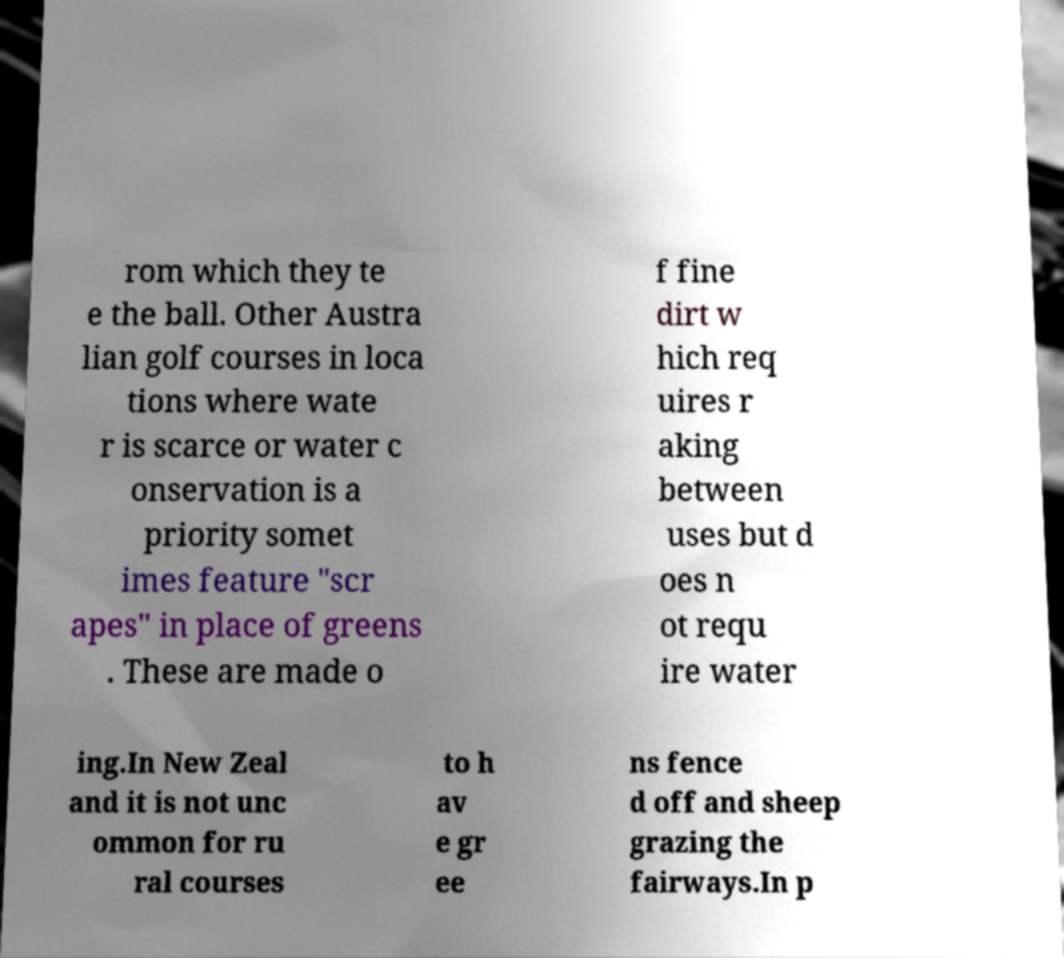There's text embedded in this image that I need extracted. Can you transcribe it verbatim? rom which they te e the ball. Other Austra lian golf courses in loca tions where wate r is scarce or water c onservation is a priority somet imes feature "scr apes" in place of greens . These are made o f fine dirt w hich req uires r aking between uses but d oes n ot requ ire water ing.In New Zeal and it is not unc ommon for ru ral courses to h av e gr ee ns fence d off and sheep grazing the fairways.In p 